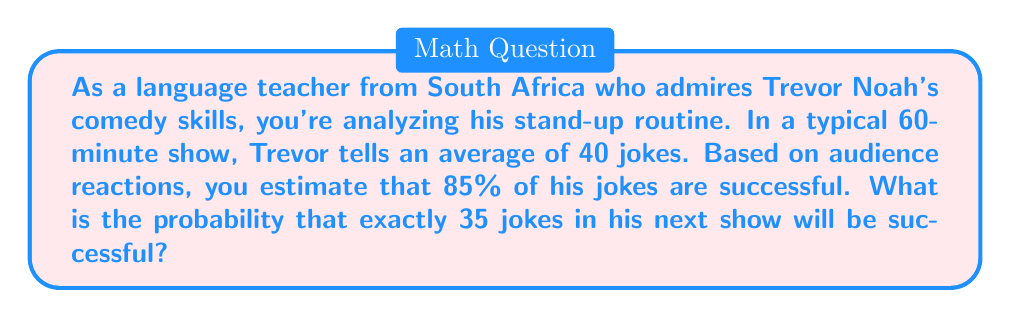Can you answer this question? To solve this problem, we need to use the binomial probability distribution. The binomial distribution is appropriate when we have a fixed number of independent trials (jokes), each with the same probability of success.

Let's define our variables:
$n = 40$ (total number of jokes)
$p = 0.85$ (probability of a successful joke)
$k = 35$ (number of successful jokes we're interested in)

The probability mass function for the binomial distribution is:

$$P(X = k) = \binom{n}{k} p^k (1-p)^{n-k}$$

Where $\binom{n}{k}$ is the binomial coefficient, calculated as:

$$\binom{n}{k} = \frac{n!}{k!(n-k)!}$$

Let's calculate step by step:

1) First, calculate the binomial coefficient:
   $$\binom{40}{35} = \frac{40!}{35!(40-35)!} = \frac{40!}{35!5!} = 658,008$$

2) Now, let's plug everything into the probability mass function:
   $$P(X = 35) = 658,008 \cdot (0.85)^{35} \cdot (1-0.85)^{40-35}$$
   $$= 658,008 \cdot (0.85)^{35} \cdot (0.15)^5$$

3) Using a calculator (or computer) to evaluate this expression:
   $$= 658,008 \cdot 0.003747 \cdot 0.0000759375$$
   $$= 0.1867$$

Therefore, the probability of exactly 35 jokes being successful in Trevor's next 60-minute show is approximately 0.1867 or 18.67%.
Answer: $P(X = 35) \approx 0.1867$ or $18.67\%$ 